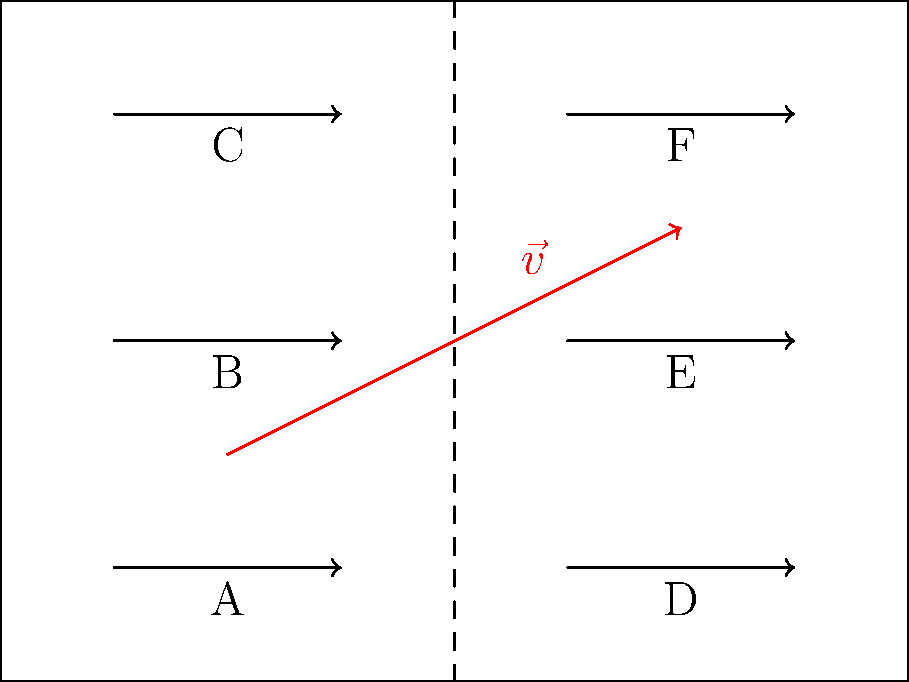In our flagship store, we're considering repositioning clothing racks to maximize customer flow and sales. The current layout is represented by the diagram, where each arrow represents a clothing rack, and the dashed line represents the central aisle. Vector $\vec{v}$ represents the proposed movement of rack B to improve store efficiency. If $\vec{v} = \langle 4, 2 \rangle$, what would be the new position of rack B, and how would this affect the store's symmetry? Propose a compensating move to maintain balance. To solve this problem, let's follow these steps:

1) First, identify the current position of rack B. From the diagram, we can see that rack B is at coordinate (2, 3).

2) The vector $\vec{v} = \langle 4, 2 \rangle$ represents the proposed movement. This means:
   - Move 4 units in the x-direction (right)
   - Move 2 units in the y-direction (up)

3) To find the new position of rack B, we add the vector to its current position:
   New position = (2, 3) + $\langle 4, 2 \rangle$ = (6, 5)

4) This move would place rack B at the same position as rack F, which is not practical. It also disrupts the store's symmetry.

5) To maintain balance, we need a compensating move. A logical choice would be to move rack E to maintain symmetry.

6) The compensating move for rack E would be $\vec{v'} = \langle -4, 2 \rangle$, which is the opposite of the x-component of $\vec{v}$ but keeps the same y-component.

7) The new position of rack E would be:
   (6, 3) + $\langle -4, 2 \rangle$ = (2, 5)

8) This creates a diagonal swap between racks B and E, maintaining the store's overall balance and symmetry.
Answer: Move B to (6,5) and E to (2,5) 